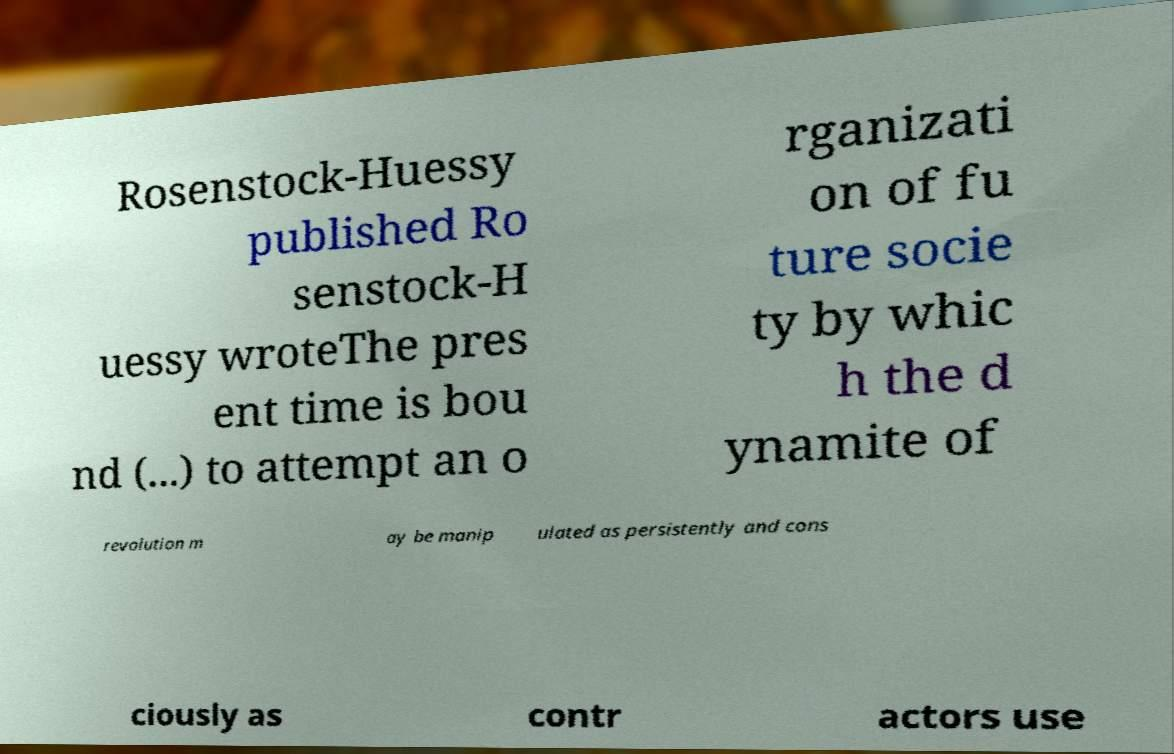Could you extract and type out the text from this image? Rosenstock-Huessy published Ro senstock-H uessy wroteThe pres ent time is bou nd (...) to attempt an o rganizati on of fu ture socie ty by whic h the d ynamite of revolution m ay be manip ulated as persistently and cons ciously as contr actors use 